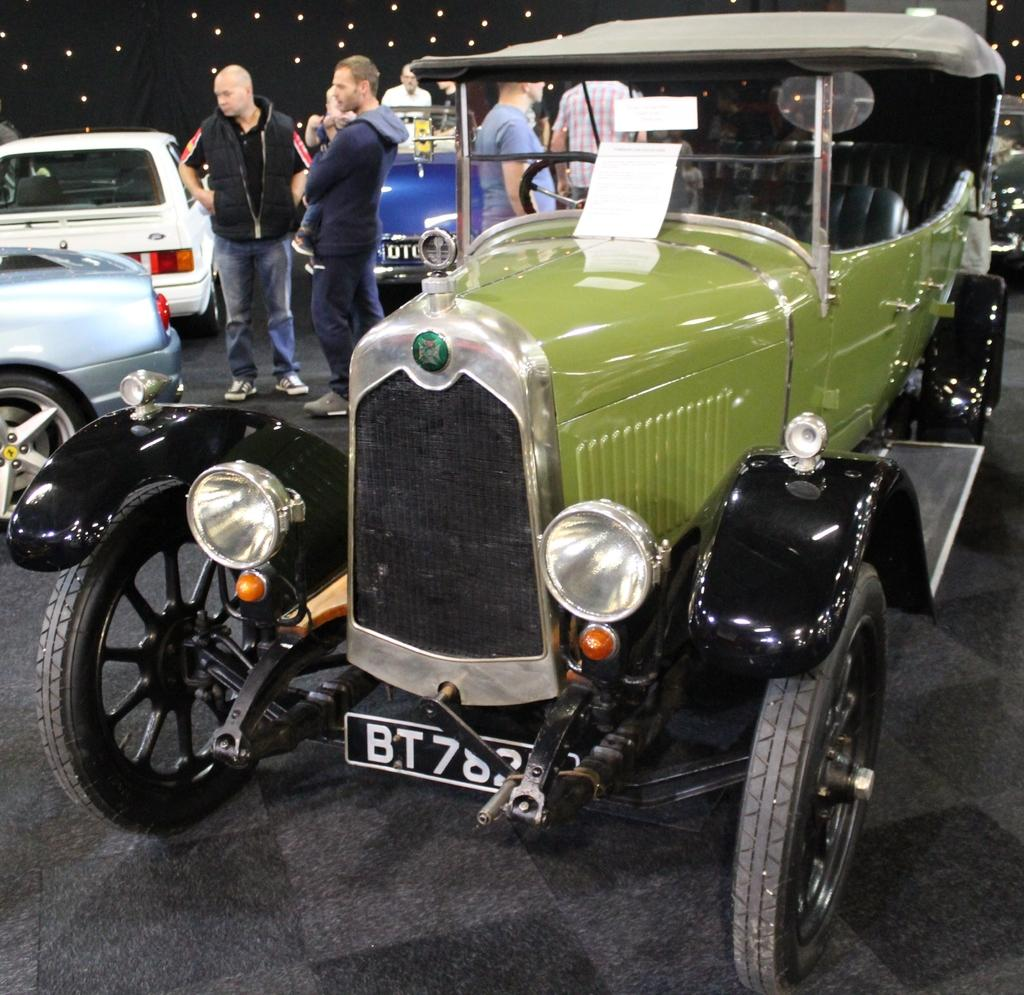What can be seen in the image that moves or transports people or goods? There are vehicles in the image that move or transport people or goods. What are the people in the image doing? The people in the image are on the floor. What feature can be seen on the roof in the image? There are lights attached to the roof in the image. How much dust is visible on the edge of the vehicles in the image? There is no mention of dust in the image, and the edge of the vehicles cannot be determined from the provided facts. 